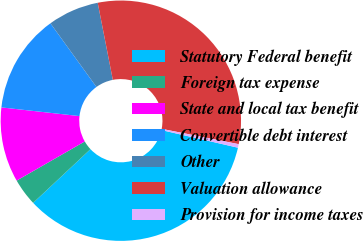<chart> <loc_0><loc_0><loc_500><loc_500><pie_chart><fcel>Statutory Federal benefit<fcel>Foreign tax expense<fcel>State and local tax benefit<fcel>Convertible debt interest<fcel>Other<fcel>Valuation allowance<fcel>Provision for income taxes<nl><fcel>34.41%<fcel>3.68%<fcel>10.07%<fcel>13.27%<fcel>6.88%<fcel>31.21%<fcel>0.48%<nl></chart> 